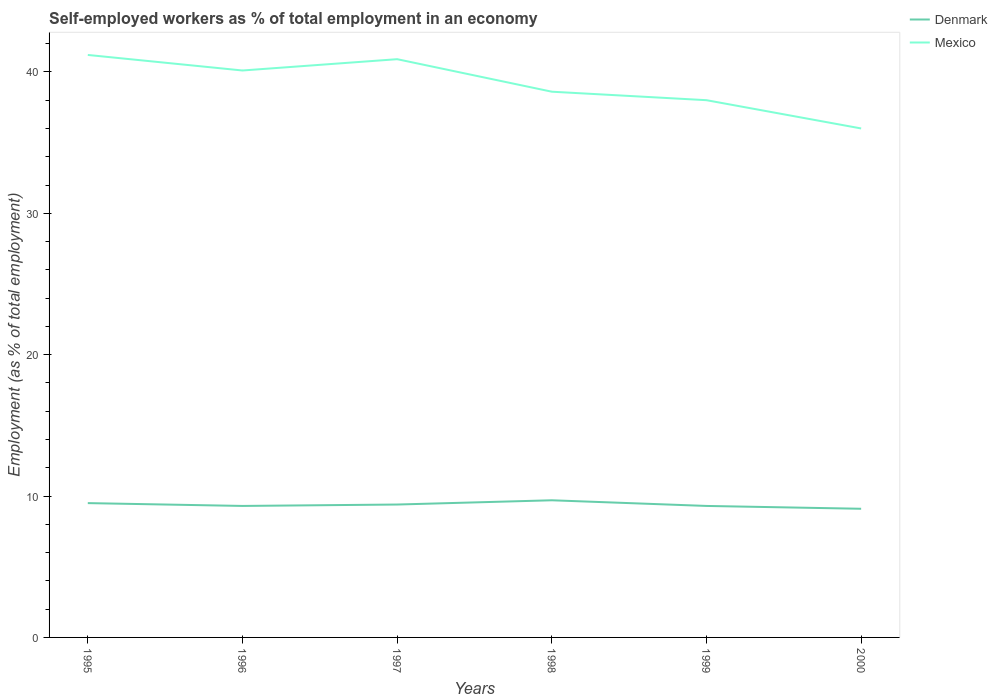Across all years, what is the maximum percentage of self-employed workers in Denmark?
Ensure brevity in your answer.  9.1. What is the total percentage of self-employed workers in Denmark in the graph?
Offer a very short reply. 0.3. What is the difference between the highest and the second highest percentage of self-employed workers in Denmark?
Offer a terse response. 0.6. Is the percentage of self-employed workers in Mexico strictly greater than the percentage of self-employed workers in Denmark over the years?
Keep it short and to the point. No. How many lines are there?
Provide a short and direct response. 2. How many years are there in the graph?
Provide a succinct answer. 6. Does the graph contain grids?
Keep it short and to the point. No. How many legend labels are there?
Your response must be concise. 2. What is the title of the graph?
Provide a short and direct response. Self-employed workers as % of total employment in an economy. What is the label or title of the X-axis?
Keep it short and to the point. Years. What is the label or title of the Y-axis?
Offer a very short reply. Employment (as % of total employment). What is the Employment (as % of total employment) in Denmark in 1995?
Your answer should be compact. 9.5. What is the Employment (as % of total employment) in Mexico in 1995?
Ensure brevity in your answer.  41.2. What is the Employment (as % of total employment) of Denmark in 1996?
Keep it short and to the point. 9.3. What is the Employment (as % of total employment) in Mexico in 1996?
Your response must be concise. 40.1. What is the Employment (as % of total employment) in Denmark in 1997?
Offer a very short reply. 9.4. What is the Employment (as % of total employment) of Mexico in 1997?
Provide a short and direct response. 40.9. What is the Employment (as % of total employment) of Denmark in 1998?
Your response must be concise. 9.7. What is the Employment (as % of total employment) of Mexico in 1998?
Offer a terse response. 38.6. What is the Employment (as % of total employment) in Denmark in 1999?
Make the answer very short. 9.3. What is the Employment (as % of total employment) in Mexico in 1999?
Offer a very short reply. 38. What is the Employment (as % of total employment) in Denmark in 2000?
Your answer should be very brief. 9.1. What is the Employment (as % of total employment) of Mexico in 2000?
Offer a terse response. 36. Across all years, what is the maximum Employment (as % of total employment) of Denmark?
Your answer should be very brief. 9.7. Across all years, what is the maximum Employment (as % of total employment) in Mexico?
Ensure brevity in your answer.  41.2. Across all years, what is the minimum Employment (as % of total employment) in Denmark?
Your response must be concise. 9.1. What is the total Employment (as % of total employment) of Denmark in the graph?
Offer a very short reply. 56.3. What is the total Employment (as % of total employment) of Mexico in the graph?
Make the answer very short. 234.8. What is the difference between the Employment (as % of total employment) of Mexico in 1995 and that in 1998?
Offer a very short reply. 2.6. What is the difference between the Employment (as % of total employment) in Denmark in 1995 and that in 1999?
Offer a terse response. 0.2. What is the difference between the Employment (as % of total employment) in Mexico in 1995 and that in 1999?
Offer a very short reply. 3.2. What is the difference between the Employment (as % of total employment) of Denmark in 1996 and that in 1997?
Give a very brief answer. -0.1. What is the difference between the Employment (as % of total employment) in Denmark in 1996 and that in 1999?
Offer a very short reply. 0. What is the difference between the Employment (as % of total employment) in Mexico in 1996 and that in 1999?
Keep it short and to the point. 2.1. What is the difference between the Employment (as % of total employment) in Denmark in 1996 and that in 2000?
Offer a terse response. 0.2. What is the difference between the Employment (as % of total employment) of Denmark in 1997 and that in 1999?
Provide a succinct answer. 0.1. What is the difference between the Employment (as % of total employment) in Denmark in 1998 and that in 2000?
Ensure brevity in your answer.  0.6. What is the difference between the Employment (as % of total employment) in Denmark in 1999 and that in 2000?
Ensure brevity in your answer.  0.2. What is the difference between the Employment (as % of total employment) of Denmark in 1995 and the Employment (as % of total employment) of Mexico in 1996?
Make the answer very short. -30.6. What is the difference between the Employment (as % of total employment) of Denmark in 1995 and the Employment (as % of total employment) of Mexico in 1997?
Provide a short and direct response. -31.4. What is the difference between the Employment (as % of total employment) in Denmark in 1995 and the Employment (as % of total employment) in Mexico in 1998?
Your response must be concise. -29.1. What is the difference between the Employment (as % of total employment) of Denmark in 1995 and the Employment (as % of total employment) of Mexico in 1999?
Give a very brief answer. -28.5. What is the difference between the Employment (as % of total employment) of Denmark in 1995 and the Employment (as % of total employment) of Mexico in 2000?
Provide a short and direct response. -26.5. What is the difference between the Employment (as % of total employment) in Denmark in 1996 and the Employment (as % of total employment) in Mexico in 1997?
Give a very brief answer. -31.6. What is the difference between the Employment (as % of total employment) in Denmark in 1996 and the Employment (as % of total employment) in Mexico in 1998?
Offer a very short reply. -29.3. What is the difference between the Employment (as % of total employment) in Denmark in 1996 and the Employment (as % of total employment) in Mexico in 1999?
Your answer should be compact. -28.7. What is the difference between the Employment (as % of total employment) of Denmark in 1996 and the Employment (as % of total employment) of Mexico in 2000?
Your response must be concise. -26.7. What is the difference between the Employment (as % of total employment) in Denmark in 1997 and the Employment (as % of total employment) in Mexico in 1998?
Make the answer very short. -29.2. What is the difference between the Employment (as % of total employment) of Denmark in 1997 and the Employment (as % of total employment) of Mexico in 1999?
Provide a short and direct response. -28.6. What is the difference between the Employment (as % of total employment) of Denmark in 1997 and the Employment (as % of total employment) of Mexico in 2000?
Your answer should be compact. -26.6. What is the difference between the Employment (as % of total employment) in Denmark in 1998 and the Employment (as % of total employment) in Mexico in 1999?
Offer a terse response. -28.3. What is the difference between the Employment (as % of total employment) of Denmark in 1998 and the Employment (as % of total employment) of Mexico in 2000?
Provide a short and direct response. -26.3. What is the difference between the Employment (as % of total employment) of Denmark in 1999 and the Employment (as % of total employment) of Mexico in 2000?
Make the answer very short. -26.7. What is the average Employment (as % of total employment) of Denmark per year?
Your answer should be very brief. 9.38. What is the average Employment (as % of total employment) in Mexico per year?
Provide a short and direct response. 39.13. In the year 1995, what is the difference between the Employment (as % of total employment) in Denmark and Employment (as % of total employment) in Mexico?
Provide a short and direct response. -31.7. In the year 1996, what is the difference between the Employment (as % of total employment) of Denmark and Employment (as % of total employment) of Mexico?
Your answer should be compact. -30.8. In the year 1997, what is the difference between the Employment (as % of total employment) of Denmark and Employment (as % of total employment) of Mexico?
Ensure brevity in your answer.  -31.5. In the year 1998, what is the difference between the Employment (as % of total employment) of Denmark and Employment (as % of total employment) of Mexico?
Provide a succinct answer. -28.9. In the year 1999, what is the difference between the Employment (as % of total employment) in Denmark and Employment (as % of total employment) in Mexico?
Your response must be concise. -28.7. In the year 2000, what is the difference between the Employment (as % of total employment) in Denmark and Employment (as % of total employment) in Mexico?
Keep it short and to the point. -26.9. What is the ratio of the Employment (as % of total employment) of Denmark in 1995 to that in 1996?
Keep it short and to the point. 1.02. What is the ratio of the Employment (as % of total employment) in Mexico in 1995 to that in 1996?
Give a very brief answer. 1.03. What is the ratio of the Employment (as % of total employment) in Denmark in 1995 to that in 1997?
Provide a succinct answer. 1.01. What is the ratio of the Employment (as % of total employment) of Mexico in 1995 to that in 1997?
Offer a terse response. 1.01. What is the ratio of the Employment (as % of total employment) of Denmark in 1995 to that in 1998?
Your answer should be compact. 0.98. What is the ratio of the Employment (as % of total employment) in Mexico in 1995 to that in 1998?
Keep it short and to the point. 1.07. What is the ratio of the Employment (as % of total employment) of Denmark in 1995 to that in 1999?
Give a very brief answer. 1.02. What is the ratio of the Employment (as % of total employment) in Mexico in 1995 to that in 1999?
Your response must be concise. 1.08. What is the ratio of the Employment (as % of total employment) in Denmark in 1995 to that in 2000?
Provide a short and direct response. 1.04. What is the ratio of the Employment (as % of total employment) of Mexico in 1995 to that in 2000?
Your answer should be very brief. 1.14. What is the ratio of the Employment (as % of total employment) in Denmark in 1996 to that in 1997?
Provide a succinct answer. 0.99. What is the ratio of the Employment (as % of total employment) of Mexico in 1996 to that in 1997?
Provide a succinct answer. 0.98. What is the ratio of the Employment (as % of total employment) in Denmark in 1996 to that in 1998?
Make the answer very short. 0.96. What is the ratio of the Employment (as % of total employment) of Mexico in 1996 to that in 1998?
Your answer should be compact. 1.04. What is the ratio of the Employment (as % of total employment) in Mexico in 1996 to that in 1999?
Provide a short and direct response. 1.06. What is the ratio of the Employment (as % of total employment) of Mexico in 1996 to that in 2000?
Offer a terse response. 1.11. What is the ratio of the Employment (as % of total employment) in Denmark in 1997 to that in 1998?
Offer a very short reply. 0.97. What is the ratio of the Employment (as % of total employment) in Mexico in 1997 to that in 1998?
Your response must be concise. 1.06. What is the ratio of the Employment (as % of total employment) in Denmark in 1997 to that in 1999?
Give a very brief answer. 1.01. What is the ratio of the Employment (as % of total employment) of Mexico in 1997 to that in 1999?
Ensure brevity in your answer.  1.08. What is the ratio of the Employment (as % of total employment) of Denmark in 1997 to that in 2000?
Keep it short and to the point. 1.03. What is the ratio of the Employment (as % of total employment) in Mexico in 1997 to that in 2000?
Make the answer very short. 1.14. What is the ratio of the Employment (as % of total employment) of Denmark in 1998 to that in 1999?
Provide a short and direct response. 1.04. What is the ratio of the Employment (as % of total employment) in Mexico in 1998 to that in 1999?
Offer a terse response. 1.02. What is the ratio of the Employment (as % of total employment) in Denmark in 1998 to that in 2000?
Give a very brief answer. 1.07. What is the ratio of the Employment (as % of total employment) in Mexico in 1998 to that in 2000?
Ensure brevity in your answer.  1.07. What is the ratio of the Employment (as % of total employment) of Mexico in 1999 to that in 2000?
Offer a very short reply. 1.06. What is the difference between the highest and the second highest Employment (as % of total employment) in Denmark?
Your response must be concise. 0.2. What is the difference between the highest and the second highest Employment (as % of total employment) in Mexico?
Provide a short and direct response. 0.3. What is the difference between the highest and the lowest Employment (as % of total employment) in Mexico?
Give a very brief answer. 5.2. 